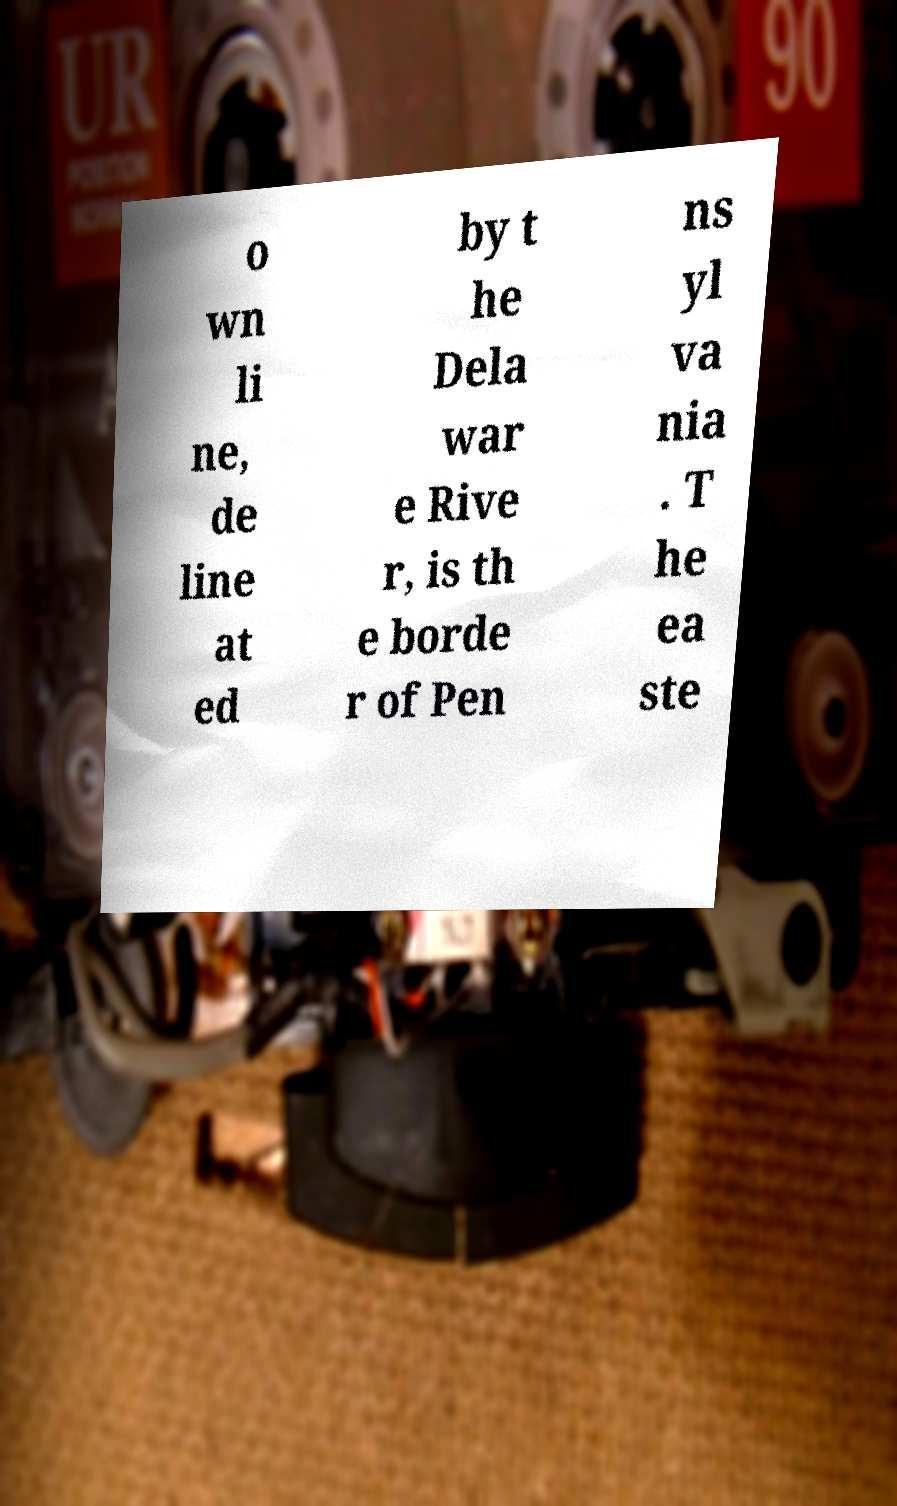For documentation purposes, I need the text within this image transcribed. Could you provide that? o wn li ne, de line at ed by t he Dela war e Rive r, is th e borde r of Pen ns yl va nia . T he ea ste 